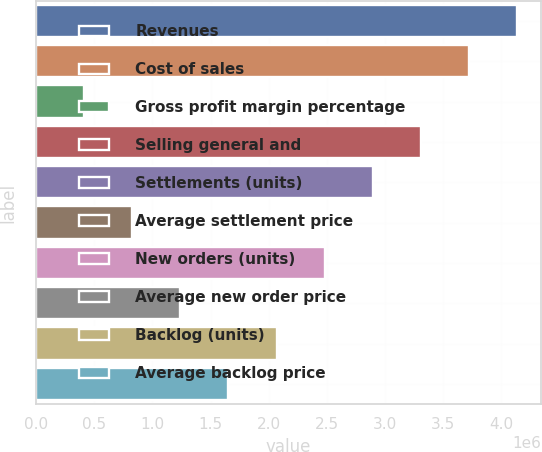Convert chart. <chart><loc_0><loc_0><loc_500><loc_500><bar_chart><fcel>Revenues<fcel>Cost of sales<fcel>Gross profit margin percentage<fcel>Selling general and<fcel>Settlements (units)<fcel>Average settlement price<fcel>New orders (units)<fcel>Average new order price<fcel>Backlog (units)<fcel>Average backlog price<nl><fcel>4.13448e+06<fcel>3.72103e+06<fcel>413462<fcel>3.30759e+06<fcel>2.89414e+06<fcel>826908<fcel>2.48069e+06<fcel>1.24035e+06<fcel>2.06725e+06<fcel>1.6538e+06<nl></chart> 